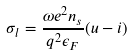Convert formula to latex. <formula><loc_0><loc_0><loc_500><loc_500>\sigma _ { l } = \frac { \omega e ^ { 2 } n _ { s } } { q ^ { 2 } \epsilon _ { F } } ( u - i )</formula> 